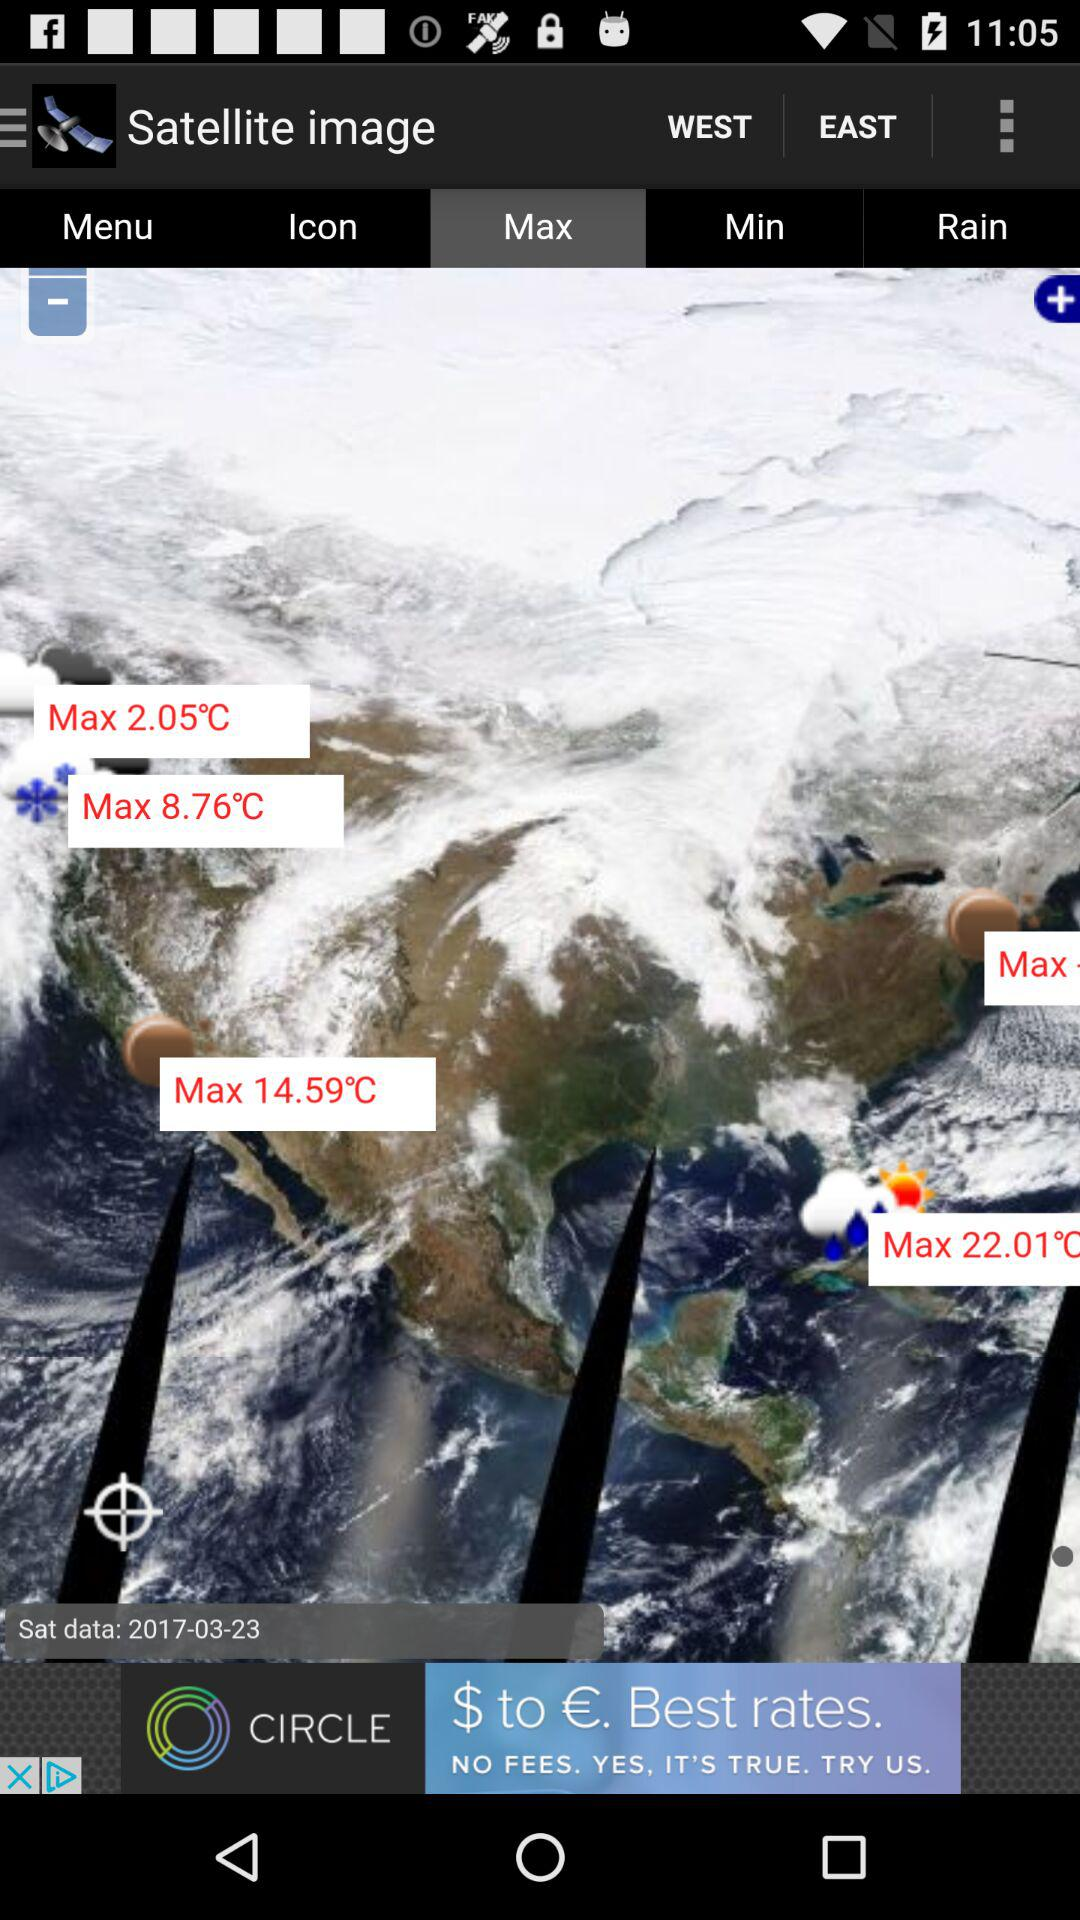What date is mentioned on the screen? The mentioned date is March 23, 2017. 